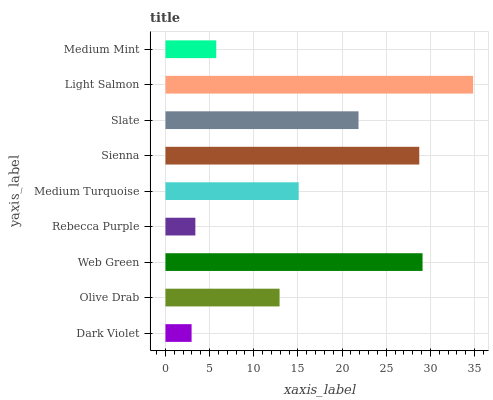Is Dark Violet the minimum?
Answer yes or no. Yes. Is Light Salmon the maximum?
Answer yes or no. Yes. Is Olive Drab the minimum?
Answer yes or no. No. Is Olive Drab the maximum?
Answer yes or no. No. Is Olive Drab greater than Dark Violet?
Answer yes or no. Yes. Is Dark Violet less than Olive Drab?
Answer yes or no. Yes. Is Dark Violet greater than Olive Drab?
Answer yes or no. No. Is Olive Drab less than Dark Violet?
Answer yes or no. No. Is Medium Turquoise the high median?
Answer yes or no. Yes. Is Medium Turquoise the low median?
Answer yes or no. Yes. Is Sienna the high median?
Answer yes or no. No. Is Web Green the low median?
Answer yes or no. No. 